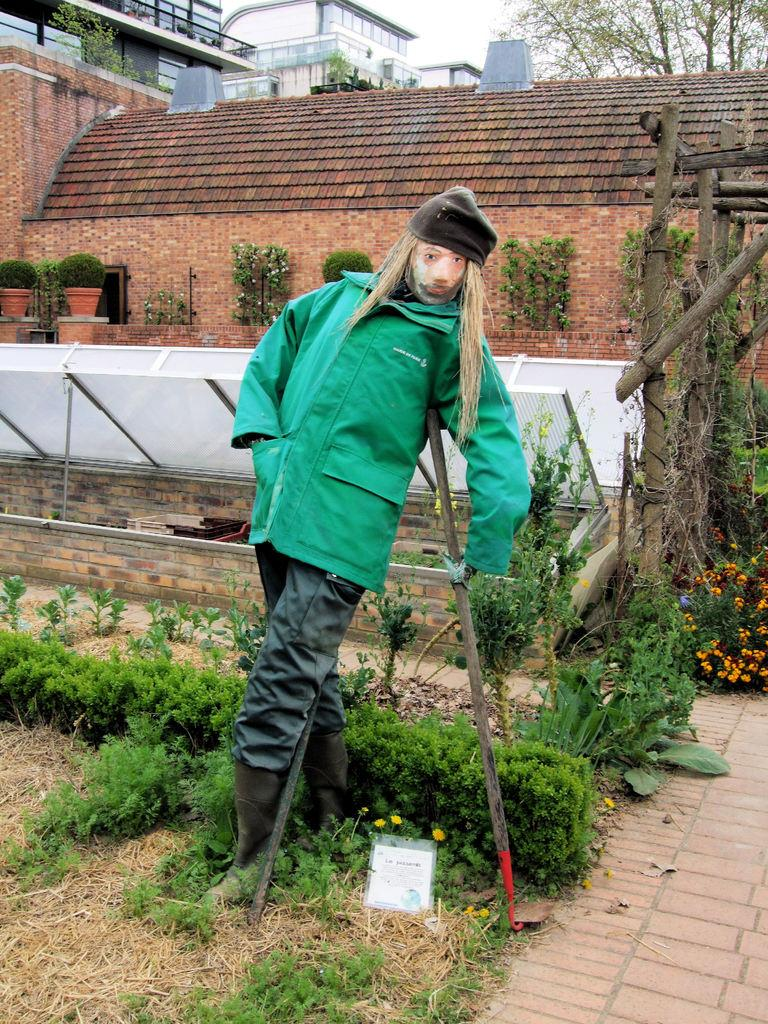What is the main subject of the image? There is a scarecrow in the image. What type of vegetation can be seen in the image? There is grass and plants with flowers in the image. What material are the poles made of in the image? The poles in the image are made of wood. What type of structures can be seen in the image? There are buildings in the image. What other natural elements are present in the image? There are trees in the image. What is the price of the pot in the image? There is no pot present in the image, so it is not possible to determine its price. 